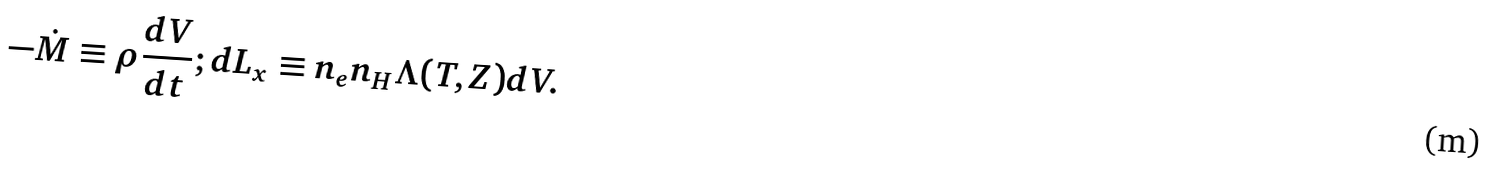<formula> <loc_0><loc_0><loc_500><loc_500>- \dot { M } \equiv \rho \frac { d V } { d t } ; d L _ { x } \equiv n _ { e } n _ { H } \Lambda ( T , Z ) d V .</formula> 